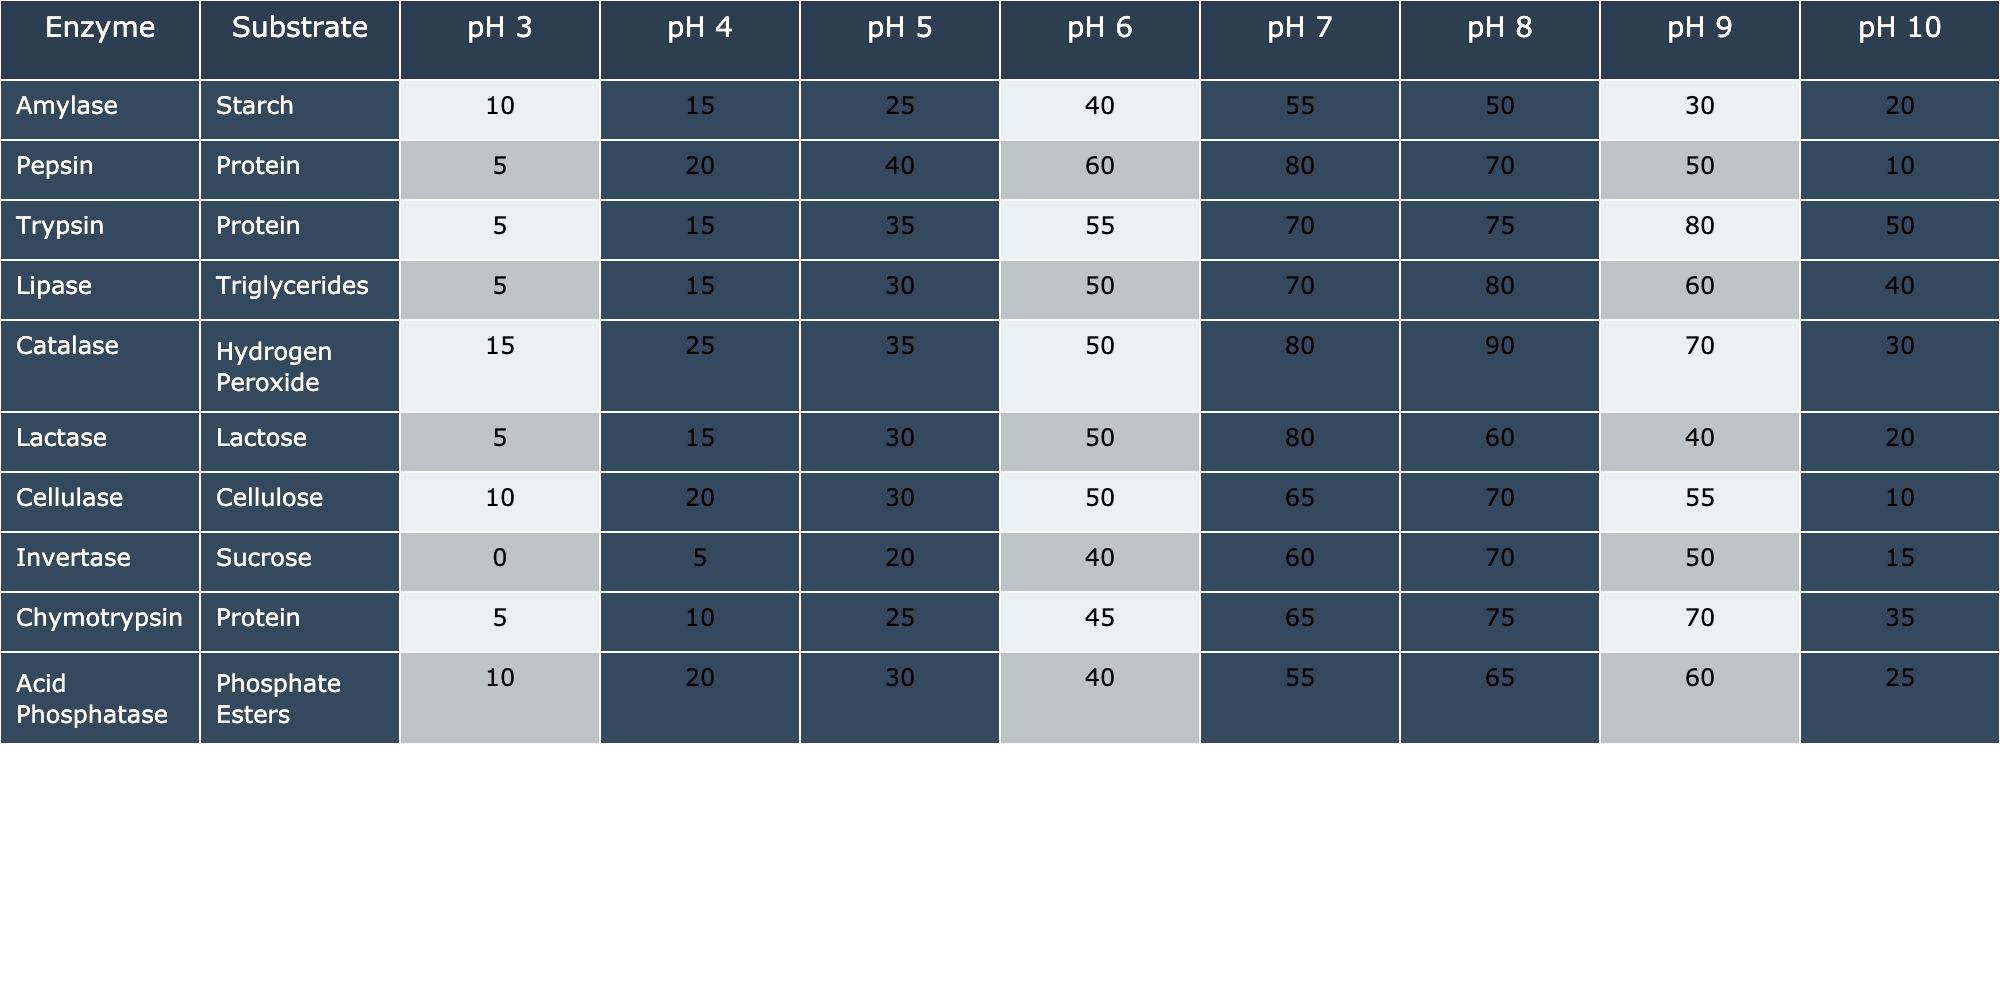What is the enzyme with the highest activity level at pH 6? By examining the values in the pH 6 column, we can see that Catalase has the highest activity level with a value of 50.
Answer: Catalase What is the substrate for Amylase? The table clearly states that Amylase acts on Starch as its substrate.
Answer: Starch At which pH does Pepsin show its peak activity? Looking at the Pepsin row, the peak activity level occurs at pH 7 with a value of 80.
Answer: pH 7 What is the average enzyme activity level for Trypsin across all pH levels? To find the average, we sum the activity levels (5 + 15 + 35 + 55 + 70 + 75 + 80 + 50 = 385) and divide by the number of pH values (8). Thus, 385/8 = 48.125.
Answer: 48.125 Is the activity level of Lipase higher at pH 8 than at pH 10? Evaluating the values for Lipase, we see 80 at pH 8 and 40 at pH 10. Therefore, Lipase has a higher activity level at pH 8.
Answer: Yes Which enzyme has the lowest activity level at pH 3? Inspecting the values in the pH 3 column, Invertase has the lowest activity level with a value of 0.
Answer: Invertase What is the total enzyme activity for Lactase from pH 3 to pH 10? Adding the activity levels of Lactase across all pH values yields (5 + 15 + 30 + 50 + 80 + 60 + 40 + 20 = 300).
Answer: 300 At which pH does Cellulase reach 50% activity or above? Checking the activity levels of Cellulase, we find it reaches 50% activity starting from pH 6 (50) up to pH 8 (70). Thus, pH 6 and above show that activity.
Answer: pH 6 and above Which enzyme shows a decrease in activity at the highest pH, pH 10? By examining the pH 10 column, we can see that Amylase activity decreases to 20, while others like Catalase drop to 30, indicating a decrease. However, Amylase has the lowest value here.
Answer: Amylase Is the activity of Acid Phosphatase higher at pH 7 than at pH 5? Evaluating Acid Phosphatase, the activity at pH 7 is 55, and at pH 5 is 30, thus confirming that it is indeed higher at pH 7.
Answer: Yes 